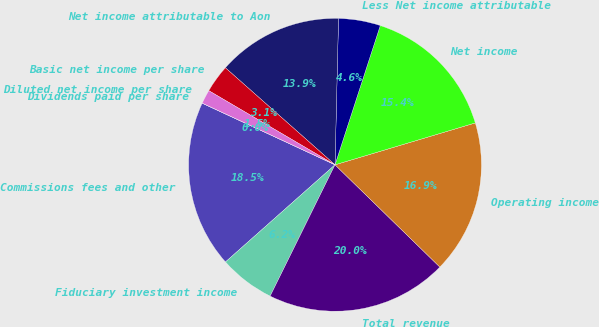Convert chart to OTSL. <chart><loc_0><loc_0><loc_500><loc_500><pie_chart><fcel>Commissions fees and other<fcel>Fiduciary investment income<fcel>Total revenue<fcel>Operating income<fcel>Net income<fcel>Less Net income attributable<fcel>Net income attributable to Aon<fcel>Basic net income per share<fcel>Diluted net income per share<fcel>Dividends paid per share<nl><fcel>18.46%<fcel>6.15%<fcel>20.0%<fcel>16.92%<fcel>15.38%<fcel>4.62%<fcel>13.85%<fcel>3.08%<fcel>1.54%<fcel>0.0%<nl></chart> 